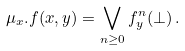<formula> <loc_0><loc_0><loc_500><loc_500>\mu _ { x } . f ( x , y ) & = \bigvee _ { n \geq 0 } f ^ { n } _ { y } ( \bot ) \, .</formula> 